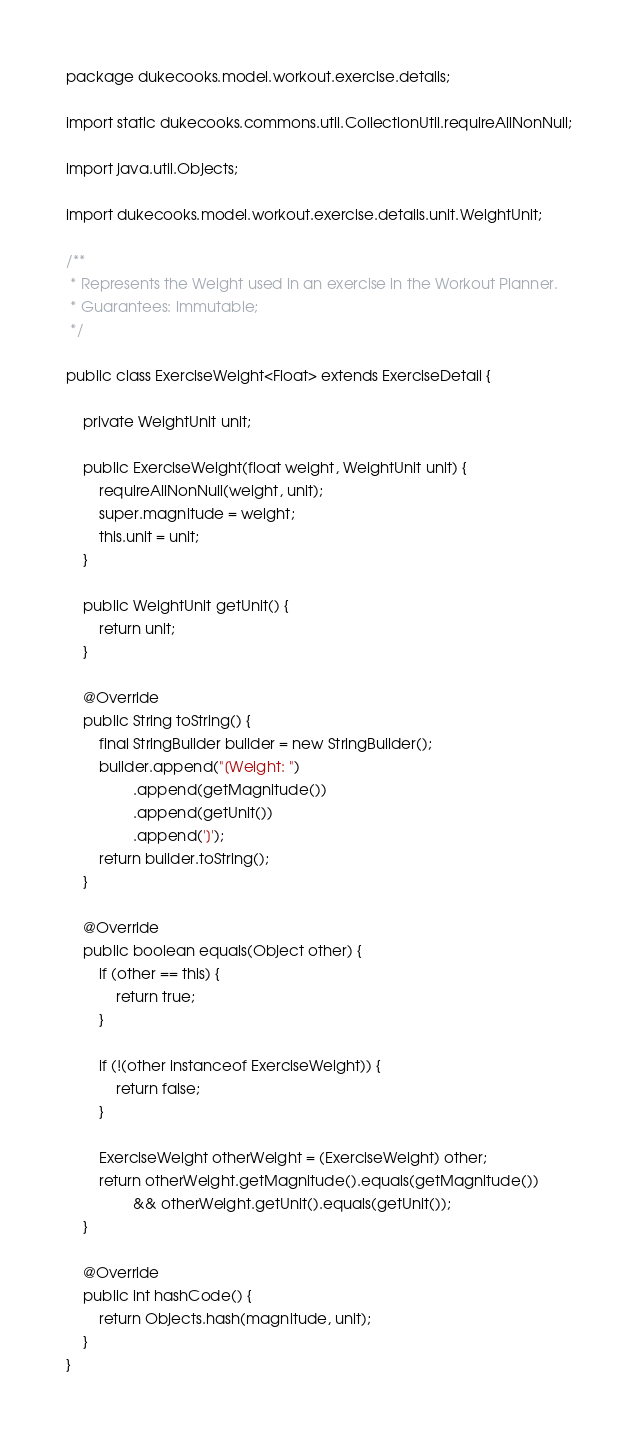<code> <loc_0><loc_0><loc_500><loc_500><_Java_>package dukecooks.model.workout.exercise.details;

import static dukecooks.commons.util.CollectionUtil.requireAllNonNull;

import java.util.Objects;

import dukecooks.model.workout.exercise.details.unit.WeightUnit;

/**
 * Represents the Weight used in an exercise in the Workout Planner.
 * Guarantees: immutable;
 */

public class ExerciseWeight<Float> extends ExerciseDetail {

    private WeightUnit unit;

    public ExerciseWeight(float weight, WeightUnit unit) {
        requireAllNonNull(weight, unit);
        super.magnitude = weight;
        this.unit = unit;
    }

    public WeightUnit getUnit() {
        return unit;
    }

    @Override
    public String toString() {
        final StringBuilder builder = new StringBuilder();
        builder.append("[Weight: ")
                .append(getMagnitude())
                .append(getUnit())
                .append(']');
        return builder.toString();
    }

    @Override
    public boolean equals(Object other) {
        if (other == this) {
            return true;
        }

        if (!(other instanceof ExerciseWeight)) {
            return false;
        }

        ExerciseWeight otherWeight = (ExerciseWeight) other;
        return otherWeight.getMagnitude().equals(getMagnitude())
                && otherWeight.getUnit().equals(getUnit());
    }

    @Override
    public int hashCode() {
        return Objects.hash(magnitude, unit);
    }
}
</code> 